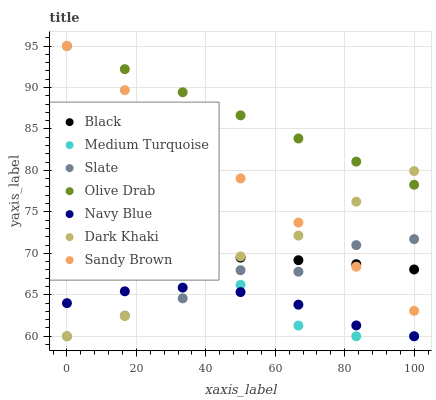Does Navy Blue have the minimum area under the curve?
Answer yes or no. Yes. Does Olive Drab have the maximum area under the curve?
Answer yes or no. Yes. Does Slate have the minimum area under the curve?
Answer yes or no. No. Does Slate have the maximum area under the curve?
Answer yes or no. No. Is Olive Drab the smoothest?
Answer yes or no. Yes. Is Slate the roughest?
Answer yes or no. Yes. Is Dark Khaki the smoothest?
Answer yes or no. No. Is Dark Khaki the roughest?
Answer yes or no. No. Does Navy Blue have the lowest value?
Answer yes or no. Yes. Does Black have the lowest value?
Answer yes or no. No. Does Olive Drab have the highest value?
Answer yes or no. Yes. Does Slate have the highest value?
Answer yes or no. No. Is Navy Blue less than Olive Drab?
Answer yes or no. Yes. Is Olive Drab greater than Navy Blue?
Answer yes or no. Yes. Does Dark Khaki intersect Sandy Brown?
Answer yes or no. Yes. Is Dark Khaki less than Sandy Brown?
Answer yes or no. No. Is Dark Khaki greater than Sandy Brown?
Answer yes or no. No. Does Navy Blue intersect Olive Drab?
Answer yes or no. No. 